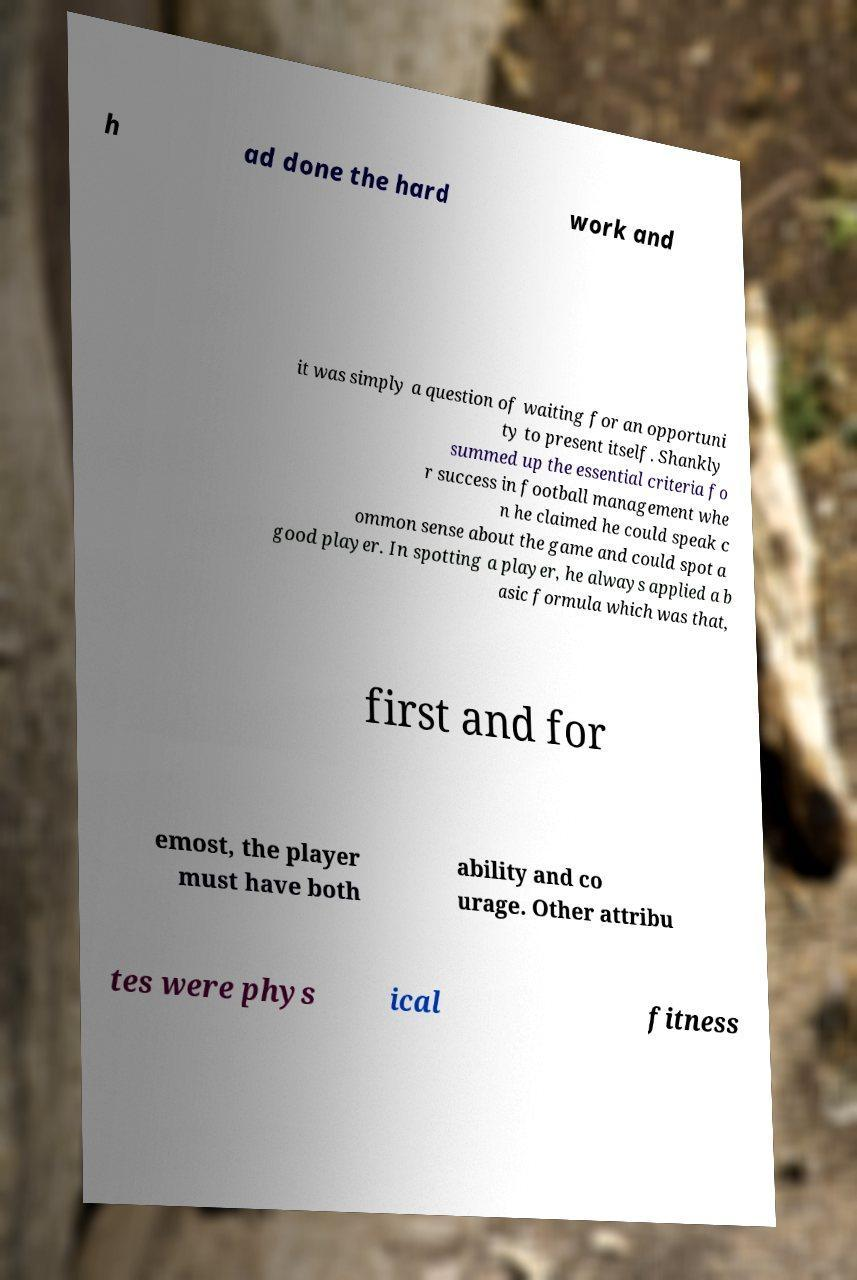There's text embedded in this image that I need extracted. Can you transcribe it verbatim? h ad done the hard work and it was simply a question of waiting for an opportuni ty to present itself. Shankly summed up the essential criteria fo r success in football management whe n he claimed he could speak c ommon sense about the game and could spot a good player. In spotting a player, he always applied a b asic formula which was that, first and for emost, the player must have both ability and co urage. Other attribu tes were phys ical fitness 